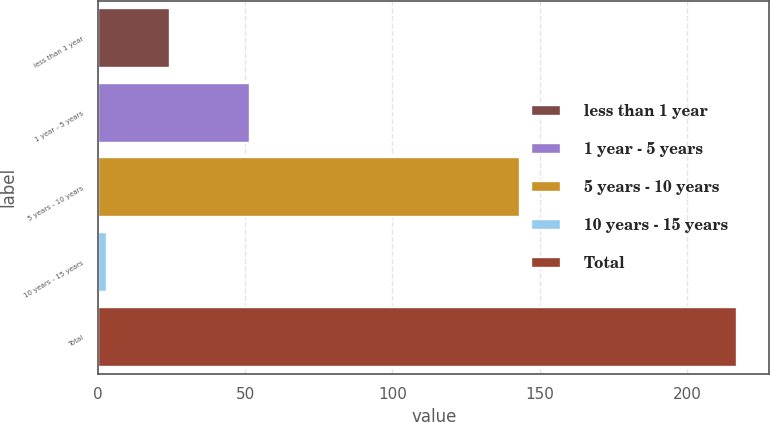Convert chart. <chart><loc_0><loc_0><loc_500><loc_500><bar_chart><fcel>less than 1 year<fcel>1 year - 5 years<fcel>5 years - 10 years<fcel>10 years - 15 years<fcel>Total<nl><fcel>24.6<fcel>51.5<fcel>143.4<fcel>3.2<fcel>217.2<nl></chart> 